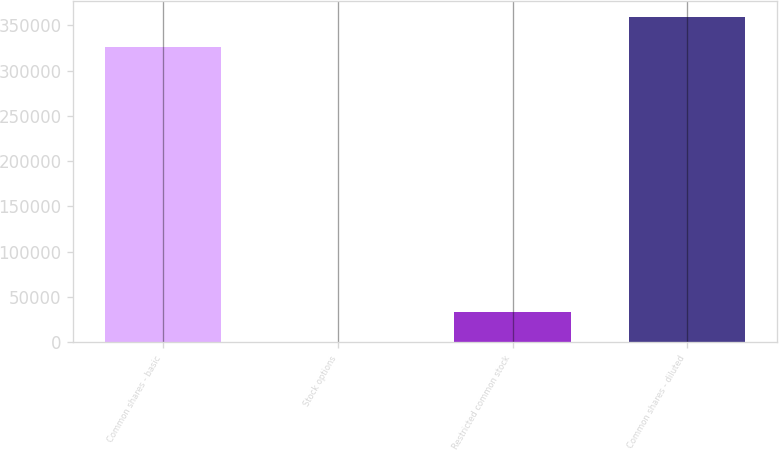<chart> <loc_0><loc_0><loc_500><loc_500><bar_chart><fcel>Common shares - basic<fcel>Stock options<fcel>Restricted common stock<fcel>Common shares - diluted<nl><fcel>325999<fcel>829<fcel>33573.8<fcel>358744<nl></chart> 